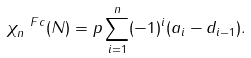Convert formula to latex. <formula><loc_0><loc_0><loc_500><loc_500>\chi ^ { \ F c } _ { n } ( N ) = p \sum _ { i = 1 } ^ { n } ( - 1 ) ^ { i } ( a _ { i } - d _ { i - 1 } ) .</formula> 